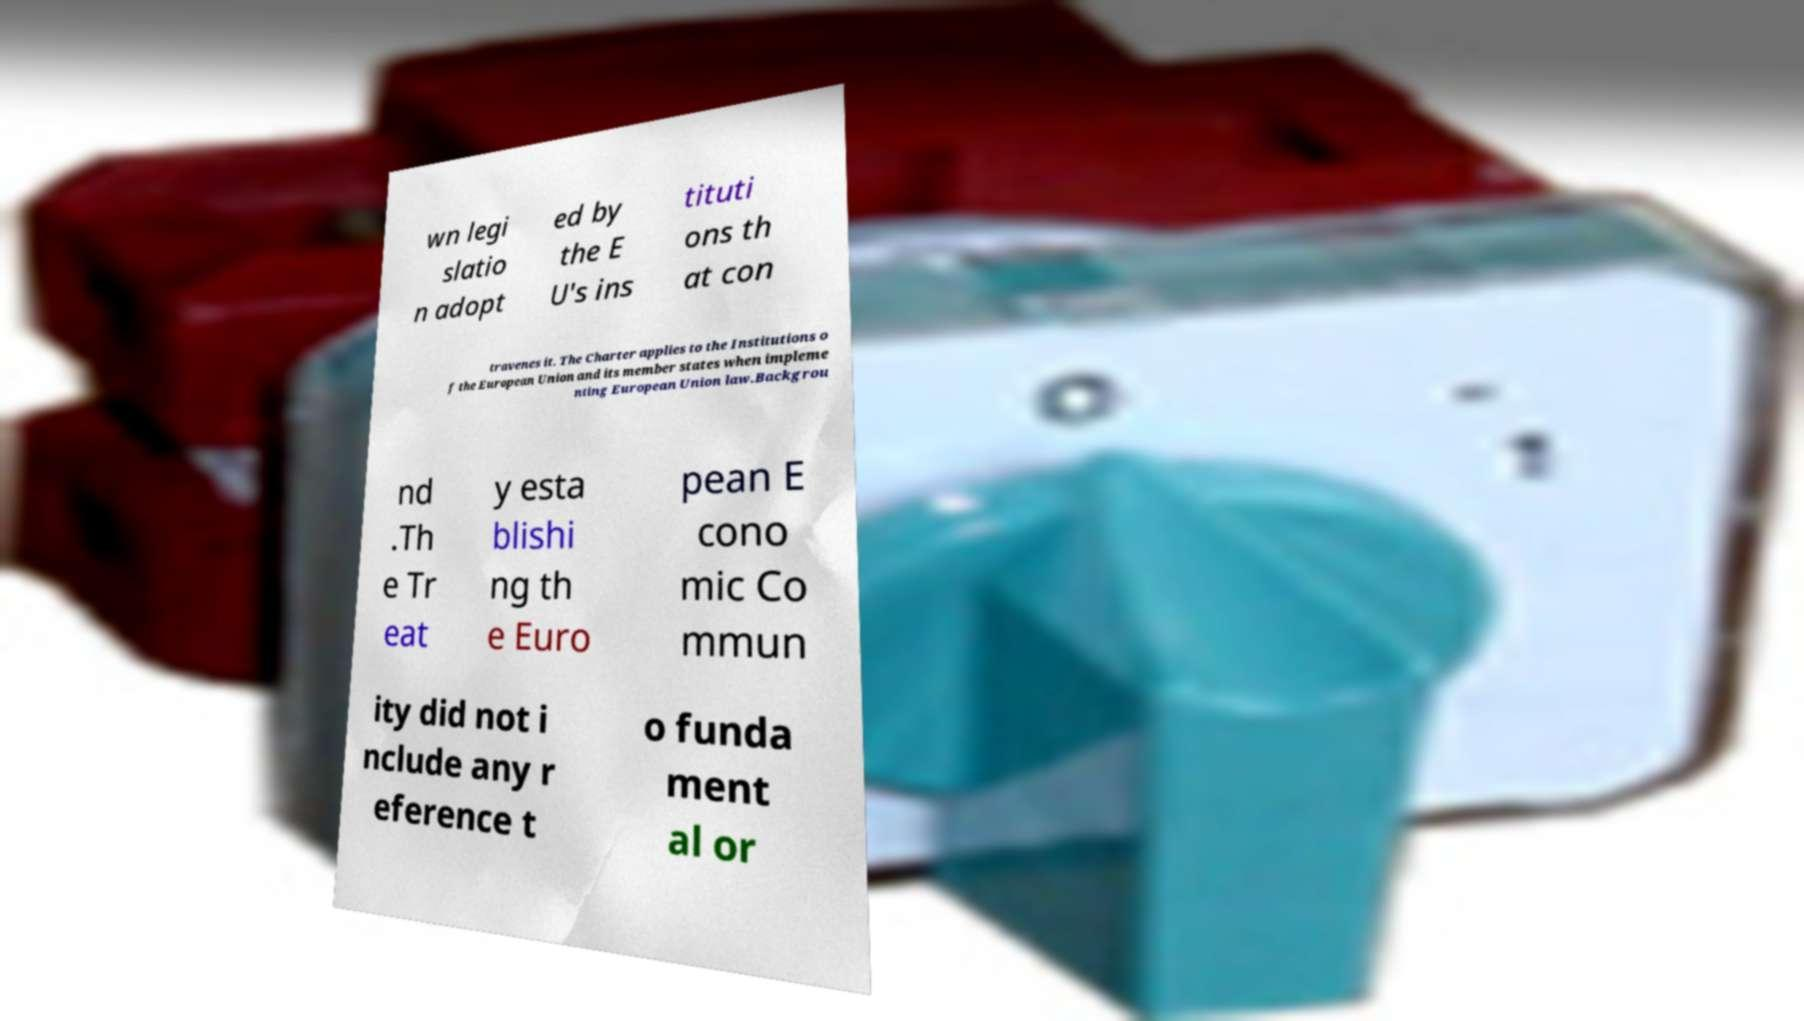Can you accurately transcribe the text from the provided image for me? wn legi slatio n adopt ed by the E U's ins tituti ons th at con travenes it. The Charter applies to the Institutions o f the European Union and its member states when impleme nting European Union law.Backgrou nd .Th e Tr eat y esta blishi ng th e Euro pean E cono mic Co mmun ity did not i nclude any r eference t o funda ment al or 